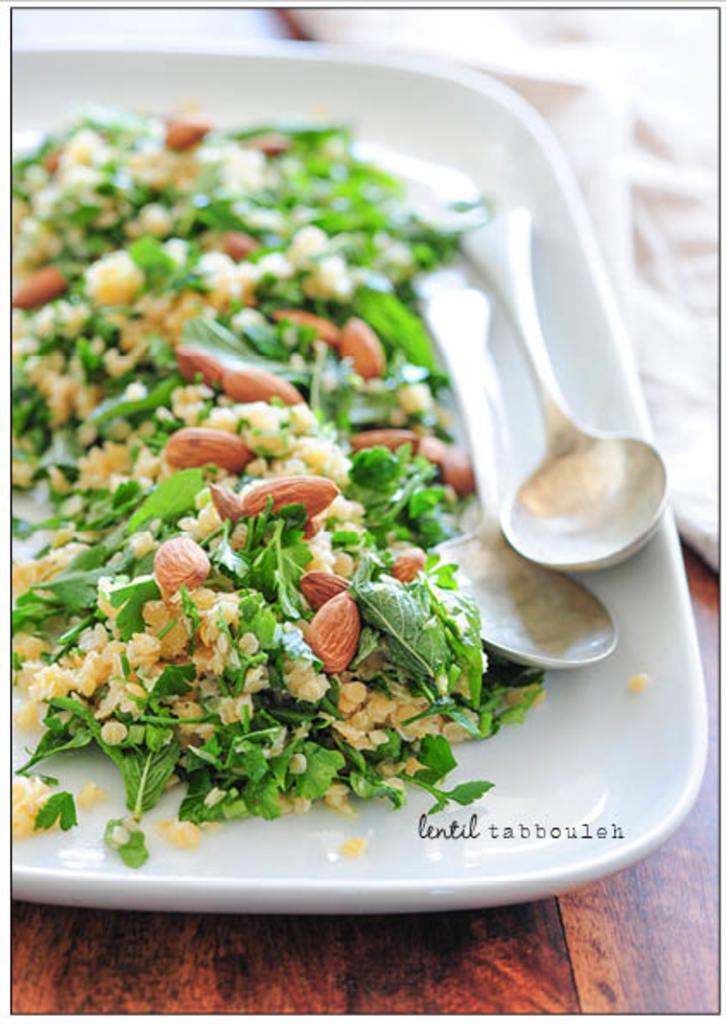Can you describe this image briefly? There is a food item and two spoons are kept in a white color plate as we can see in the middle of this image, and this plate is kept on a wooden surface. 